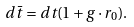<formula> <loc_0><loc_0><loc_500><loc_500>d \bar { t } = d t ( 1 + g \cdot r _ { 0 } ) .</formula> 